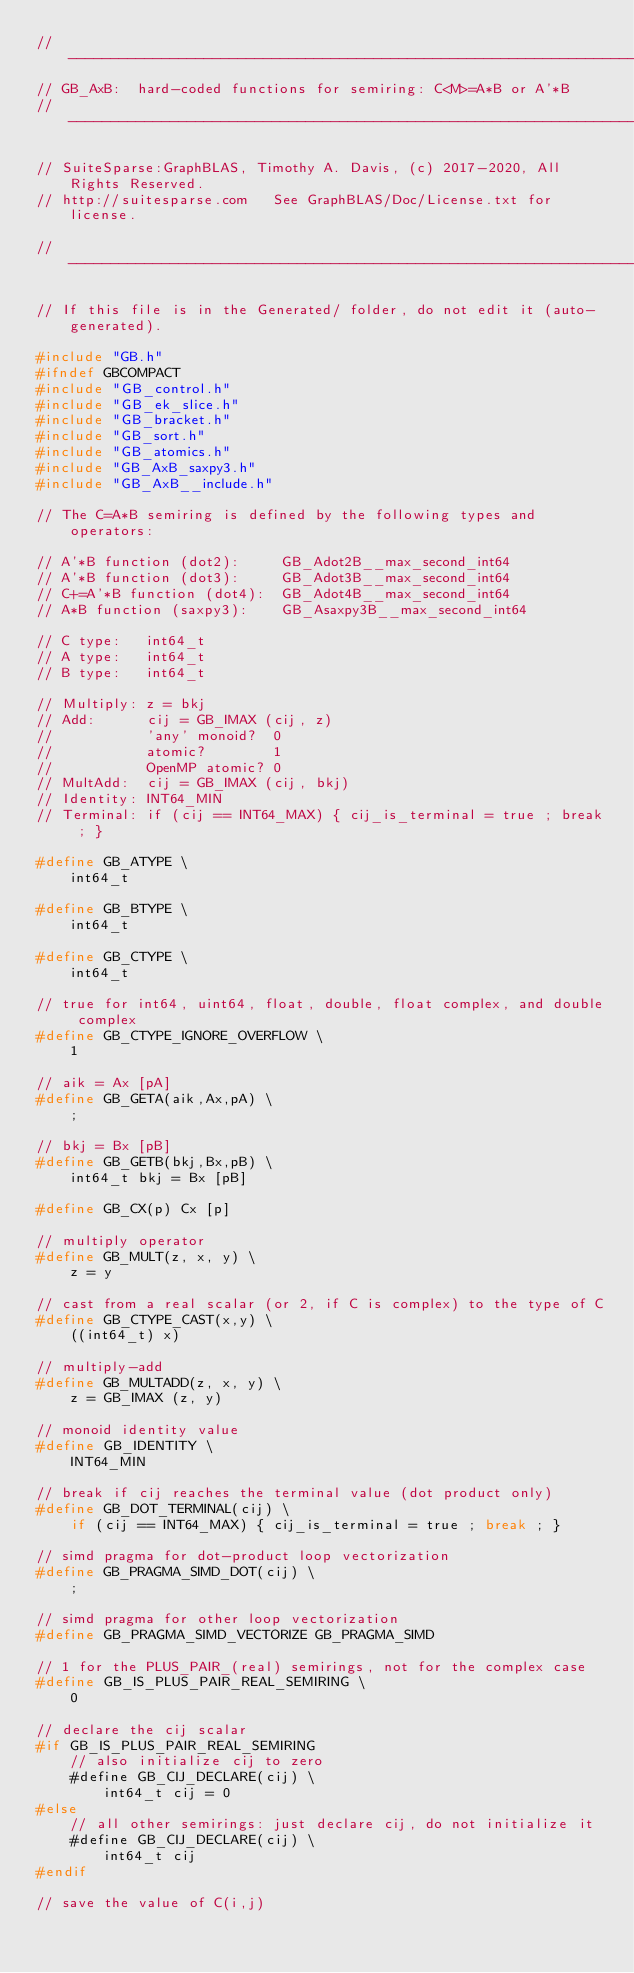Convert code to text. <code><loc_0><loc_0><loc_500><loc_500><_C_>//------------------------------------------------------------------------------
// GB_AxB:  hard-coded functions for semiring: C<M>=A*B or A'*B
//------------------------------------------------------------------------------

// SuiteSparse:GraphBLAS, Timothy A. Davis, (c) 2017-2020, All Rights Reserved.
// http://suitesparse.com   See GraphBLAS/Doc/License.txt for license.

//------------------------------------------------------------------------------

// If this file is in the Generated/ folder, do not edit it (auto-generated).

#include "GB.h"
#ifndef GBCOMPACT
#include "GB_control.h"
#include "GB_ek_slice.h"
#include "GB_bracket.h"
#include "GB_sort.h"
#include "GB_atomics.h"
#include "GB_AxB_saxpy3.h"
#include "GB_AxB__include.h"

// The C=A*B semiring is defined by the following types and operators:

// A'*B function (dot2):     GB_Adot2B__max_second_int64
// A'*B function (dot3):     GB_Adot3B__max_second_int64
// C+=A'*B function (dot4):  GB_Adot4B__max_second_int64
// A*B function (saxpy3):    GB_Asaxpy3B__max_second_int64

// C type:   int64_t
// A type:   int64_t
// B type:   int64_t

// Multiply: z = bkj
// Add:      cij = GB_IMAX (cij, z)
//           'any' monoid?  0
//           atomic?        1
//           OpenMP atomic? 0
// MultAdd:  cij = GB_IMAX (cij, bkj)
// Identity: INT64_MIN
// Terminal: if (cij == INT64_MAX) { cij_is_terminal = true ; break ; }

#define GB_ATYPE \
    int64_t

#define GB_BTYPE \
    int64_t

#define GB_CTYPE \
    int64_t

// true for int64, uint64, float, double, float complex, and double complex 
#define GB_CTYPE_IGNORE_OVERFLOW \
    1

// aik = Ax [pA]
#define GB_GETA(aik,Ax,pA) \
    ;

// bkj = Bx [pB]
#define GB_GETB(bkj,Bx,pB) \
    int64_t bkj = Bx [pB]

#define GB_CX(p) Cx [p]

// multiply operator
#define GB_MULT(z, x, y) \
    z = y

// cast from a real scalar (or 2, if C is complex) to the type of C
#define GB_CTYPE_CAST(x,y) \
    ((int64_t) x)

// multiply-add
#define GB_MULTADD(z, x, y) \
    z = GB_IMAX (z, y)

// monoid identity value
#define GB_IDENTITY \
    INT64_MIN

// break if cij reaches the terminal value (dot product only)
#define GB_DOT_TERMINAL(cij) \
    if (cij == INT64_MAX) { cij_is_terminal = true ; break ; }

// simd pragma for dot-product loop vectorization
#define GB_PRAGMA_SIMD_DOT(cij) \
    ;

// simd pragma for other loop vectorization
#define GB_PRAGMA_SIMD_VECTORIZE GB_PRAGMA_SIMD

// 1 for the PLUS_PAIR_(real) semirings, not for the complex case
#define GB_IS_PLUS_PAIR_REAL_SEMIRING \
    0

// declare the cij scalar
#if GB_IS_PLUS_PAIR_REAL_SEMIRING
    // also initialize cij to zero
    #define GB_CIJ_DECLARE(cij) \
        int64_t cij = 0
#else
    // all other semirings: just declare cij, do not initialize it
    #define GB_CIJ_DECLARE(cij) \
        int64_t cij
#endif

// save the value of C(i,j)</code> 